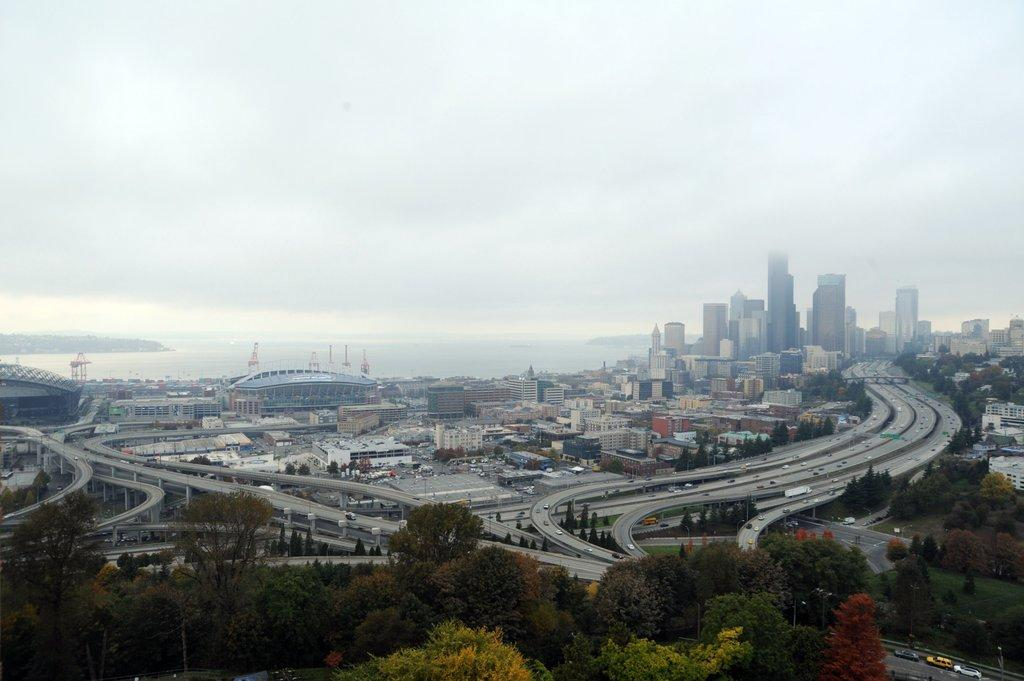What is located at the center of the image? There are buildings and roads at the center of the image. What is moving along the roads in the image? There are vehicles on the roads. What type of vegetation is at the bottom of the image? There are trees at the bottom of the image. What natural feature can be seen in the background of the image? There is a river in the background of the image. What is visible above the buildings and trees in the image? The sky is visible in the background of the image. Can you see any toes in the image? There are no toes visible in the image. What type of feather is present in the image? There are no feathers present in the image. 